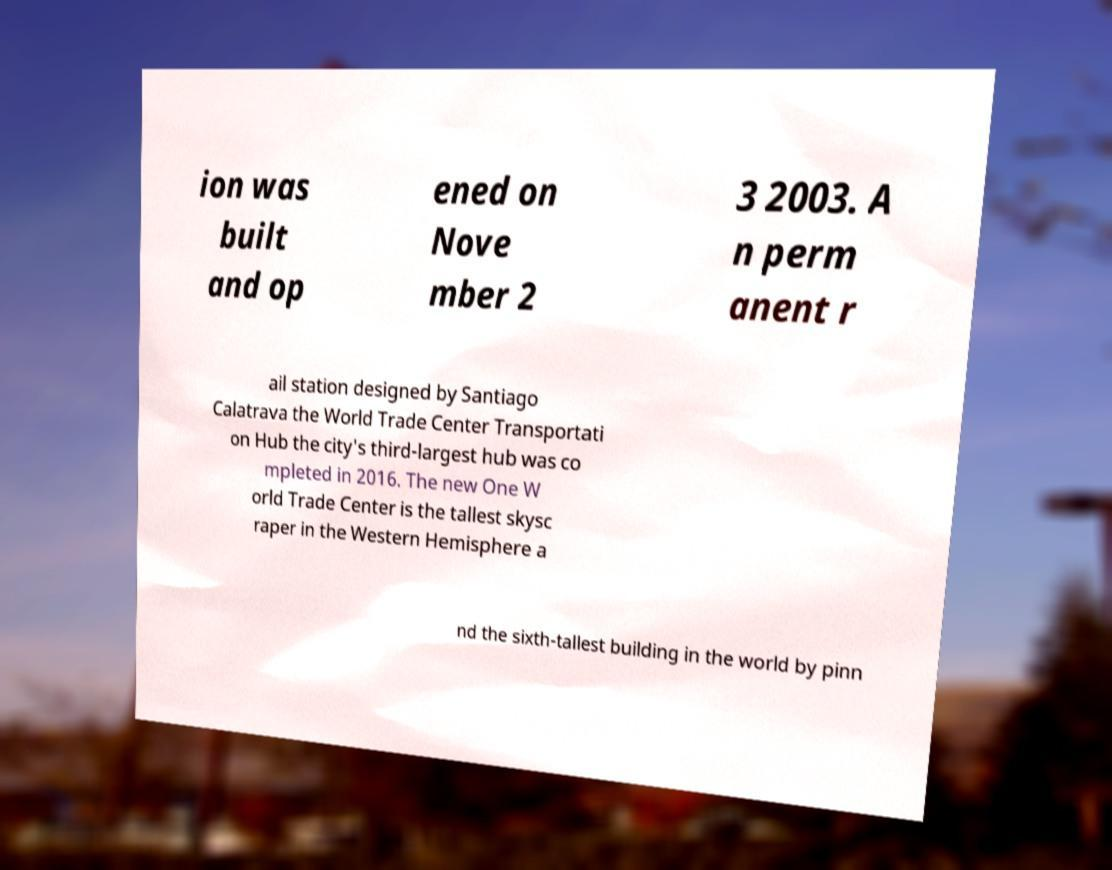There's text embedded in this image that I need extracted. Can you transcribe it verbatim? ion was built and op ened on Nove mber 2 3 2003. A n perm anent r ail station designed by Santiago Calatrava the World Trade Center Transportati on Hub the city's third-largest hub was co mpleted in 2016. The new One W orld Trade Center is the tallest skysc raper in the Western Hemisphere a nd the sixth-tallest building in the world by pinn 